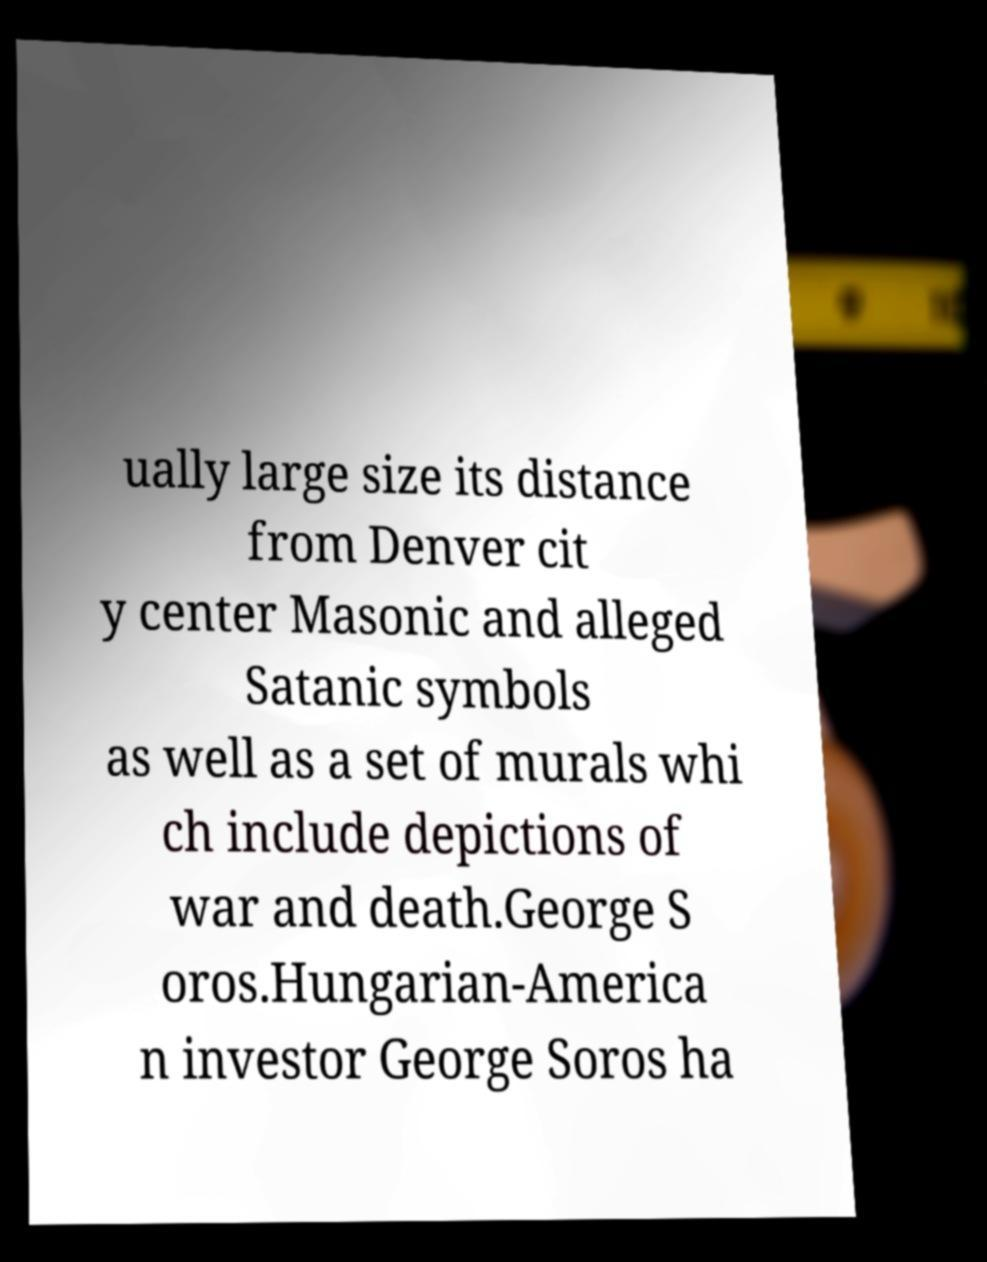What messages or text are displayed in this image? I need them in a readable, typed format. ually large size its distance from Denver cit y center Masonic and alleged Satanic symbols as well as a set of murals whi ch include depictions of war and death.George S oros.Hungarian-America n investor George Soros ha 